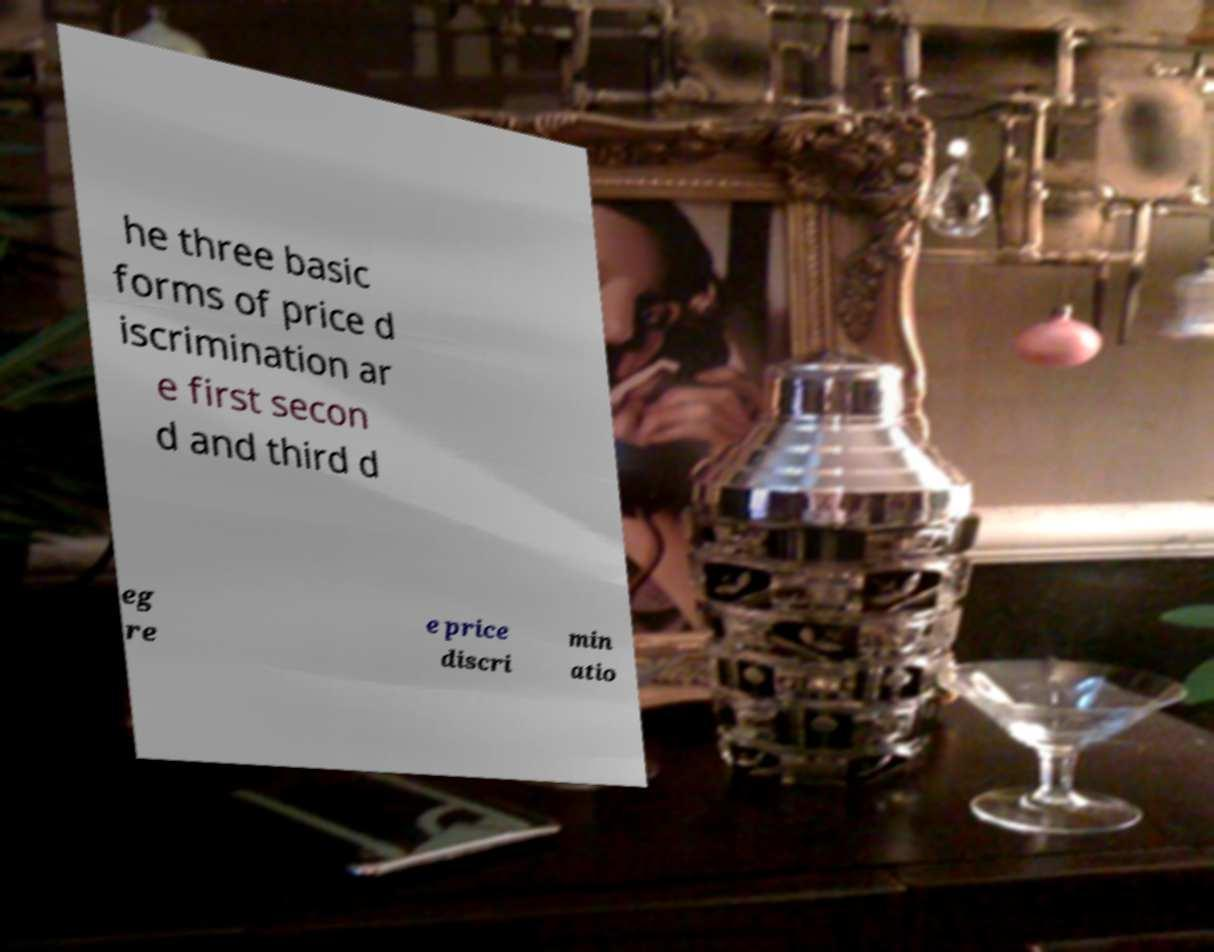Can you accurately transcribe the text from the provided image for me? he three basic forms of price d iscrimination ar e first secon d and third d eg re e price discri min atio 